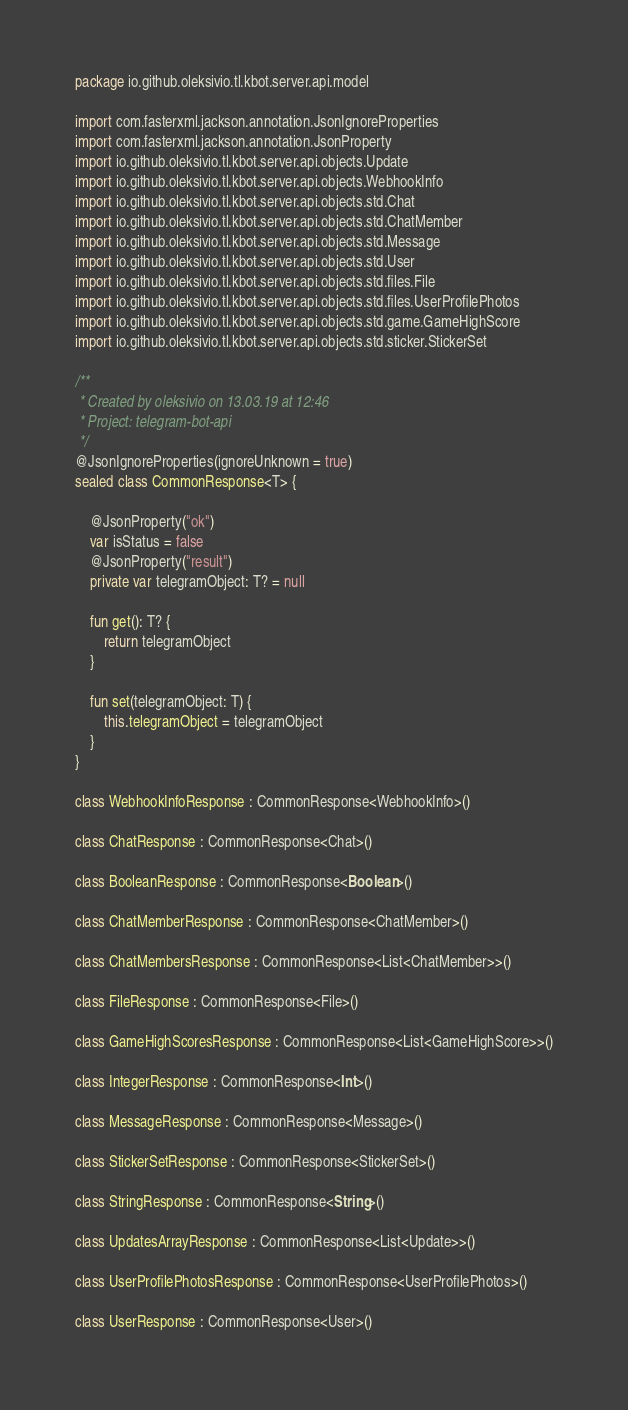<code> <loc_0><loc_0><loc_500><loc_500><_Kotlin_>package io.github.oleksivio.tl.kbot.server.api.model

import com.fasterxml.jackson.annotation.JsonIgnoreProperties
import com.fasterxml.jackson.annotation.JsonProperty
import io.github.oleksivio.tl.kbot.server.api.objects.Update
import io.github.oleksivio.tl.kbot.server.api.objects.WebhookInfo
import io.github.oleksivio.tl.kbot.server.api.objects.std.Chat
import io.github.oleksivio.tl.kbot.server.api.objects.std.ChatMember
import io.github.oleksivio.tl.kbot.server.api.objects.std.Message
import io.github.oleksivio.tl.kbot.server.api.objects.std.User
import io.github.oleksivio.tl.kbot.server.api.objects.std.files.File
import io.github.oleksivio.tl.kbot.server.api.objects.std.files.UserProfilePhotos
import io.github.oleksivio.tl.kbot.server.api.objects.std.game.GameHighScore
import io.github.oleksivio.tl.kbot.server.api.objects.std.sticker.StickerSet

/**
 * Created by oleksivio on 13.03.19 at 12:46
 * Project: telegram-bot-api
 */
@JsonIgnoreProperties(ignoreUnknown = true)
sealed class CommonResponse<T> {

    @JsonProperty("ok")
    var isStatus = false
    @JsonProperty("result")
    private var telegramObject: T? = null

    fun get(): T? {
        return telegramObject
    }

    fun set(telegramObject: T) {
        this.telegramObject = telegramObject
    }
}

class WebhookInfoResponse : CommonResponse<WebhookInfo>()

class ChatResponse : CommonResponse<Chat>()

class BooleanResponse : CommonResponse<Boolean>()

class ChatMemberResponse : CommonResponse<ChatMember>()

class ChatMembersResponse : CommonResponse<List<ChatMember>>()

class FileResponse : CommonResponse<File>()

class GameHighScoresResponse : CommonResponse<List<GameHighScore>>()

class IntegerResponse : CommonResponse<Int>()

class MessageResponse : CommonResponse<Message>()

class StickerSetResponse : CommonResponse<StickerSet>()

class StringResponse : CommonResponse<String>()

class UpdatesArrayResponse : CommonResponse<List<Update>>()

class UserProfilePhotosResponse : CommonResponse<UserProfilePhotos>()

class UserResponse : CommonResponse<User>()

</code> 